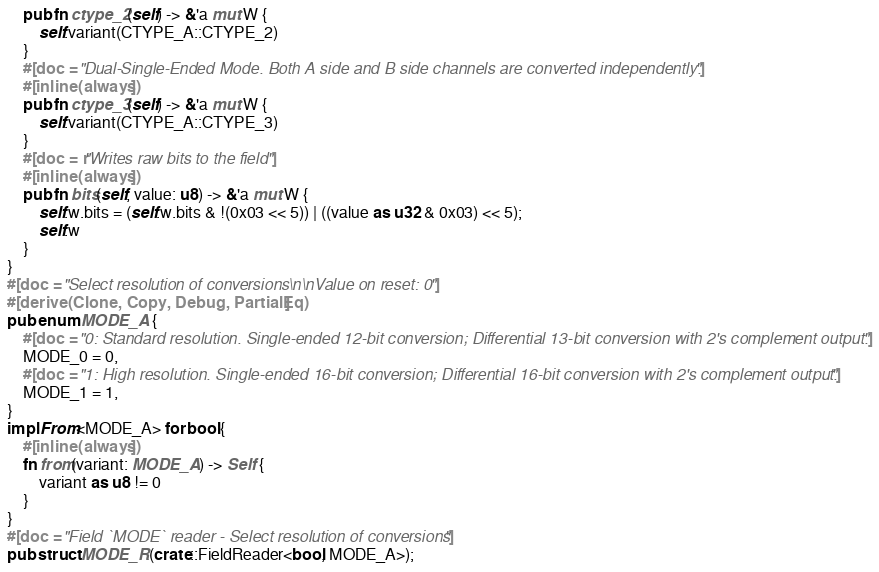Convert code to text. <code><loc_0><loc_0><loc_500><loc_500><_Rust_>    pub fn ctype_2(self) -> &'a mut W {
        self.variant(CTYPE_A::CTYPE_2)
    }
    #[doc = "Dual-Single-Ended Mode. Both A side and B side channels are converted independently."]
    #[inline(always)]
    pub fn ctype_3(self) -> &'a mut W {
        self.variant(CTYPE_A::CTYPE_3)
    }
    #[doc = r"Writes raw bits to the field"]
    #[inline(always)]
    pub fn bits(self, value: u8) -> &'a mut W {
        self.w.bits = (self.w.bits & !(0x03 << 5)) | ((value as u32 & 0x03) << 5);
        self.w
    }
}
#[doc = "Select resolution of conversions\n\nValue on reset: 0"]
#[derive(Clone, Copy, Debug, PartialEq)]
pub enum MODE_A {
    #[doc = "0: Standard resolution. Single-ended 12-bit conversion; Differential 13-bit conversion with 2's complement output."]
    MODE_0 = 0,
    #[doc = "1: High resolution. Single-ended 16-bit conversion; Differential 16-bit conversion with 2's complement output."]
    MODE_1 = 1,
}
impl From<MODE_A> for bool {
    #[inline(always)]
    fn from(variant: MODE_A) -> Self {
        variant as u8 != 0
    }
}
#[doc = "Field `MODE` reader - Select resolution of conversions"]
pub struct MODE_R(crate::FieldReader<bool, MODE_A>);</code> 